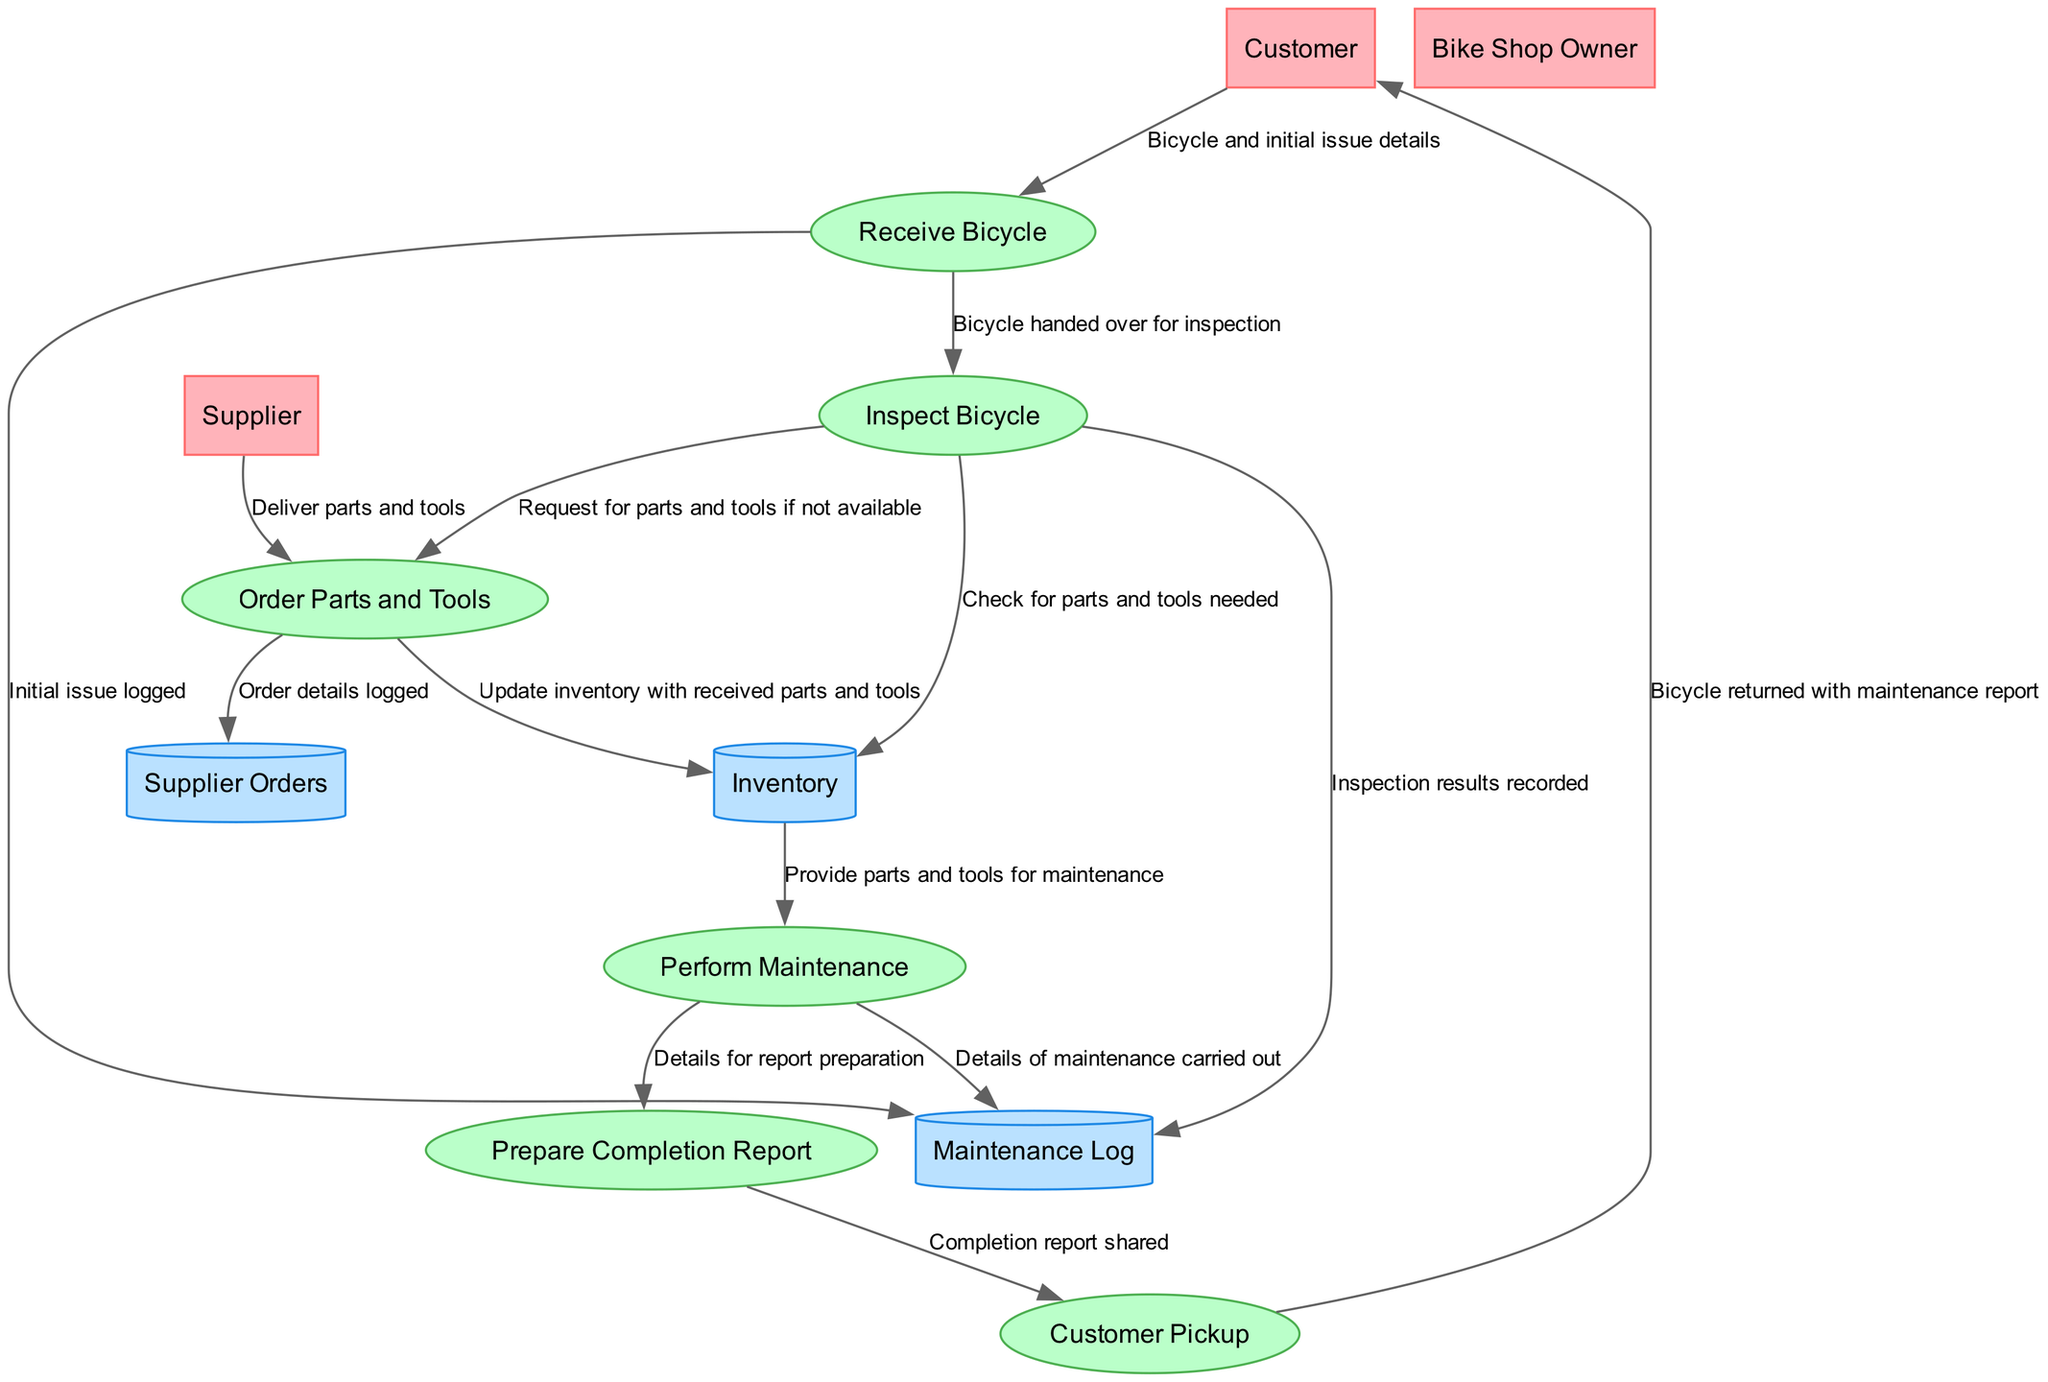What's the first process in the diagram? The first process is indicated by its position and the flow of data originating from the Customer. This is the "Receive Bicycle" process where the customer brings the bicycle for maintenance.
Answer: Receive Bicycle How many entities are there in the diagram? By counting the nodes labeled as entities, there are three: Customer, Bike Shop Owner, and Supplier.
Answer: 3 What data flows from "Inspect Bicycle" to "Order Parts and Tools"? The diagram shows that the flow coming from "Inspect Bicycle" is a request for parts and tools if they are not available, indicating the need for additional resources to proceed with maintenance.
Answer: Request for parts and tools if not available Which process prepares the completion report? The "Prepare Completion Report" process is explicitly mentioned in the diagram, indicating that it is responsible for documenting the maintenance performed.
Answer: Prepare Completion Report How many data stores are displayed in the diagram? By inspecting the nodes labeled as data stores, there are three distinct stores: Maintenance Log, Inventory, and Supplier Orders.
Answer: 3 What is the final step that returns the bicycle to the customer? The final step illustrated in the data flow sequence is "Customer Pickup," which signifies the return of the bicycle along with the maintenance report.
Answer: Customer Pickup What flows from "Perform Maintenance" to "Prepare Completion Report"? The flow consists of details related to the maintenance that has been carried out, which are necessary for compiling the completion report.
Answer: Details for report preparation What is logged in the Maintenance Log after receiving the bicycle? Following the "Receive Bicycle" process, the initial issues of the bicycle are logged into the Maintenance Log, keeping a record of customer complaints and bicycle status.
Answer: Initial issue logged 